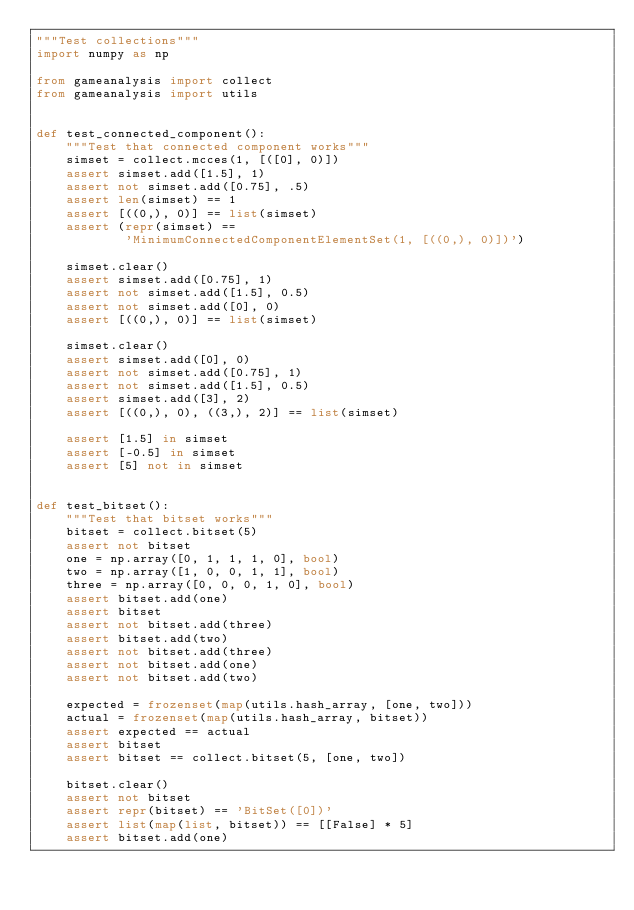<code> <loc_0><loc_0><loc_500><loc_500><_Python_>"""Test collections"""
import numpy as np

from gameanalysis import collect
from gameanalysis import utils


def test_connected_component():
    """Test that connected component works"""
    simset = collect.mcces(1, [([0], 0)])
    assert simset.add([1.5], 1)
    assert not simset.add([0.75], .5)
    assert len(simset) == 1
    assert [((0,), 0)] == list(simset)
    assert (repr(simset) ==
            'MinimumConnectedComponentElementSet(1, [((0,), 0)])')

    simset.clear()
    assert simset.add([0.75], 1)
    assert not simset.add([1.5], 0.5)
    assert not simset.add([0], 0)
    assert [((0,), 0)] == list(simset)

    simset.clear()
    assert simset.add([0], 0)
    assert not simset.add([0.75], 1)
    assert not simset.add([1.5], 0.5)
    assert simset.add([3], 2)
    assert [((0,), 0), ((3,), 2)] == list(simset)

    assert [1.5] in simset
    assert [-0.5] in simset
    assert [5] not in simset


def test_bitset():
    """Test that bitset works"""
    bitset = collect.bitset(5)
    assert not bitset
    one = np.array([0, 1, 1, 1, 0], bool)
    two = np.array([1, 0, 0, 1, 1], bool)
    three = np.array([0, 0, 0, 1, 0], bool)
    assert bitset.add(one)
    assert bitset
    assert not bitset.add(three)
    assert bitset.add(two)
    assert not bitset.add(three)
    assert not bitset.add(one)
    assert not bitset.add(two)

    expected = frozenset(map(utils.hash_array, [one, two]))
    actual = frozenset(map(utils.hash_array, bitset))
    assert expected == actual
    assert bitset
    assert bitset == collect.bitset(5, [one, two])

    bitset.clear()
    assert not bitset
    assert repr(bitset) == 'BitSet([0])'
    assert list(map(list, bitset)) == [[False] * 5]
    assert bitset.add(one)
</code> 